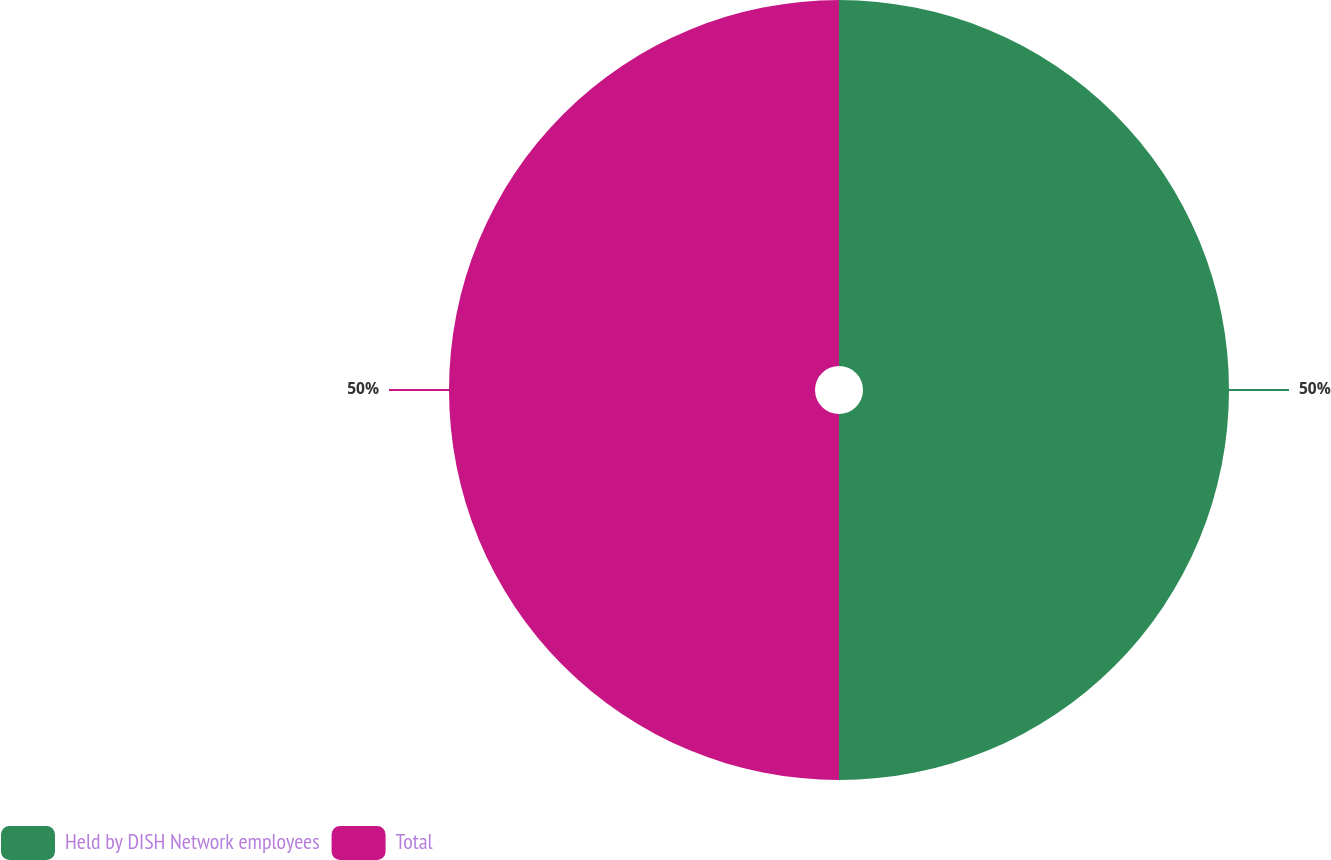Convert chart to OTSL. <chart><loc_0><loc_0><loc_500><loc_500><pie_chart><fcel>Held by DISH Network employees<fcel>Total<nl><fcel>50.0%<fcel>50.0%<nl></chart> 